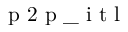<formula> <loc_0><loc_0><loc_500><loc_500>p 2 p \_ i t l</formula> 